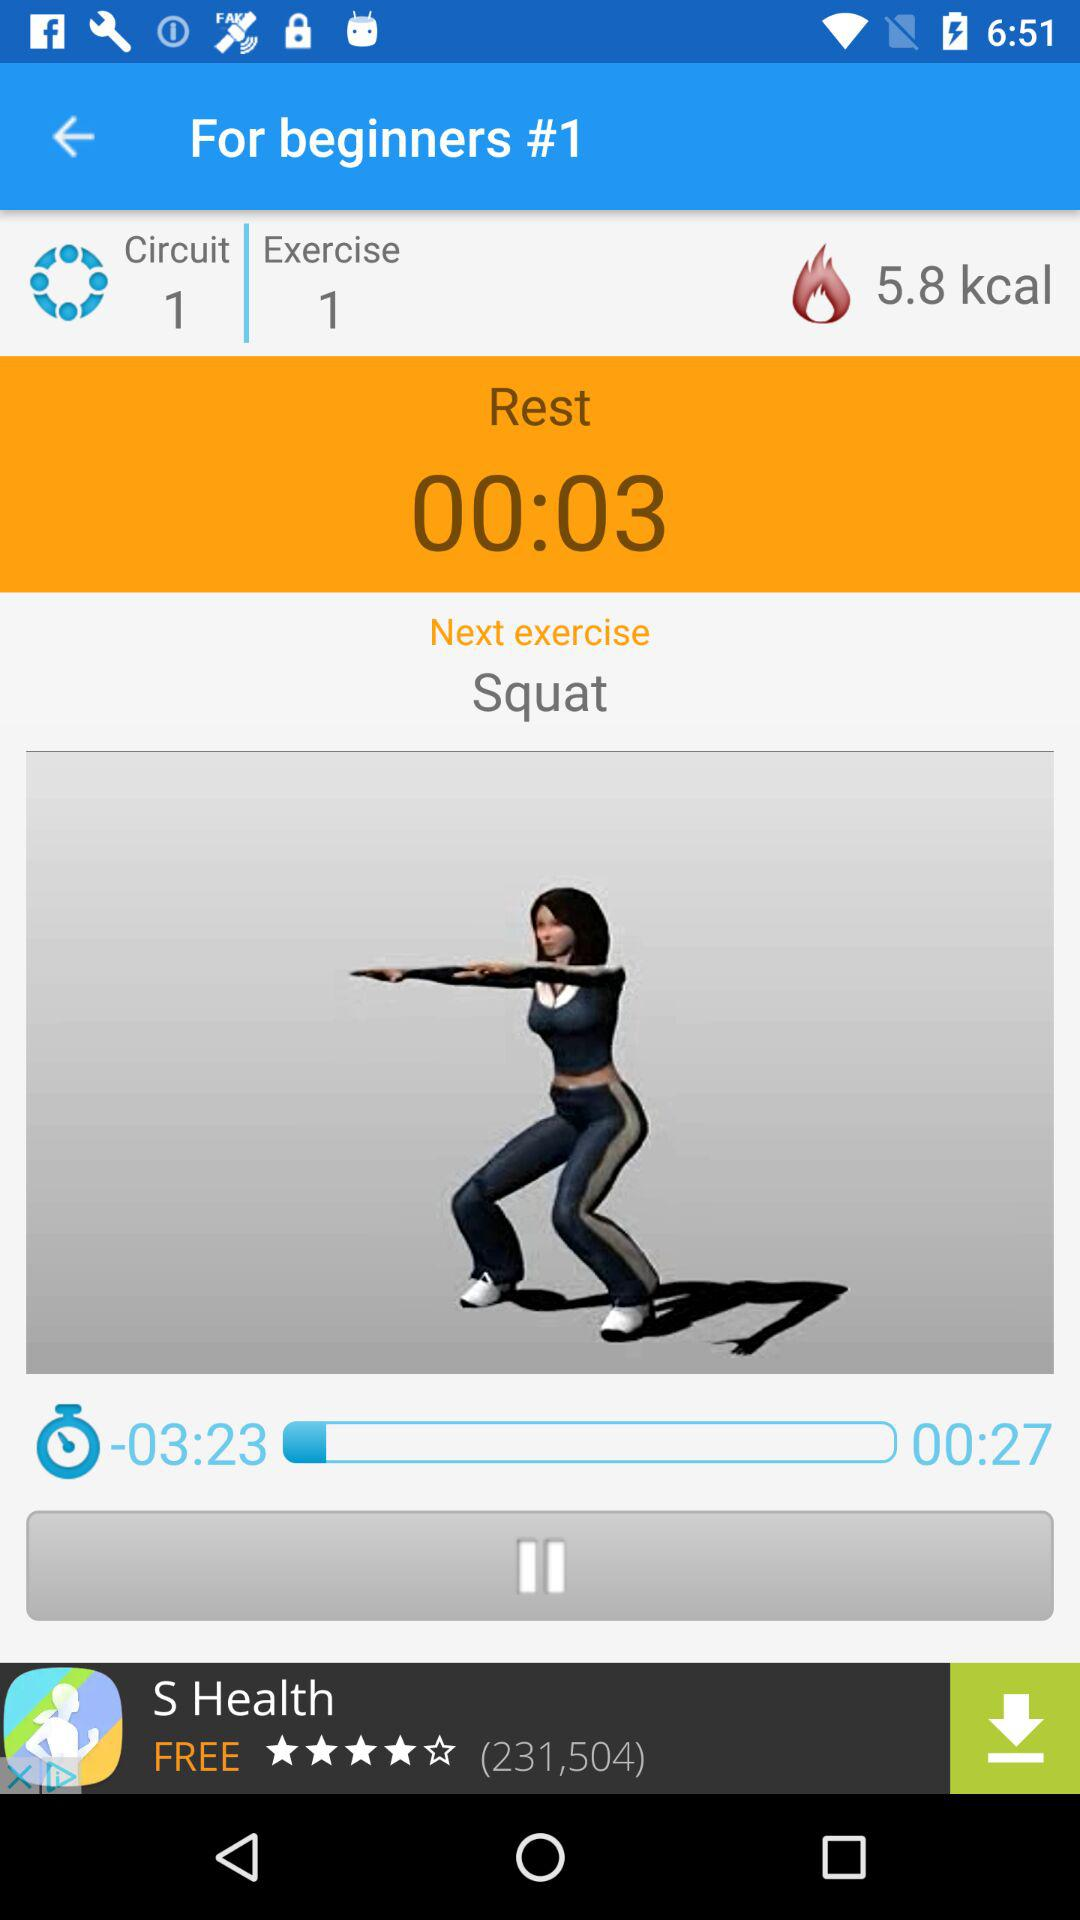How many circuits are there? There is 1 circuit. 